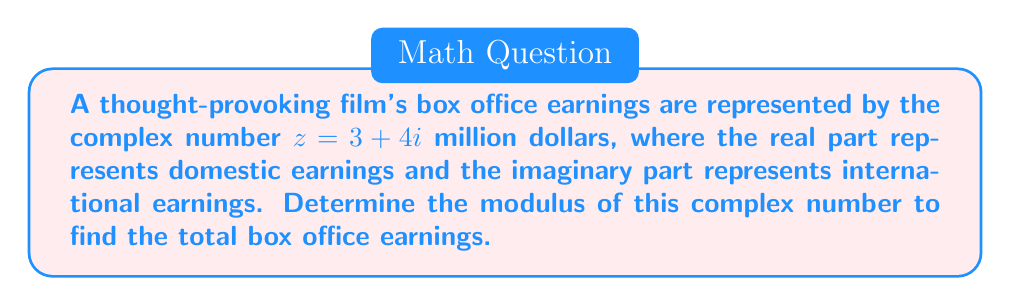Can you answer this question? To find the modulus of a complex number $z = a + bi$, we use the formula:

$$|z| = \sqrt{a^2 + b^2}$$

Where $|z|$ represents the modulus of the complex number.

For our given complex number $z = 3 + 4i$:
$a = 3$ (domestic earnings in millions)
$b = 4$ (international earnings in millions)

Substituting these values into the formula:

$$|z| = \sqrt{3^2 + 4^2}$$

$$|z| = \sqrt{9 + 16}$$

$$|z| = \sqrt{25}$$

$$|z| = 5$$

Therefore, the modulus of the complex number representing the box office earnings is 5 million dollars.
Answer: $5$ million dollars 